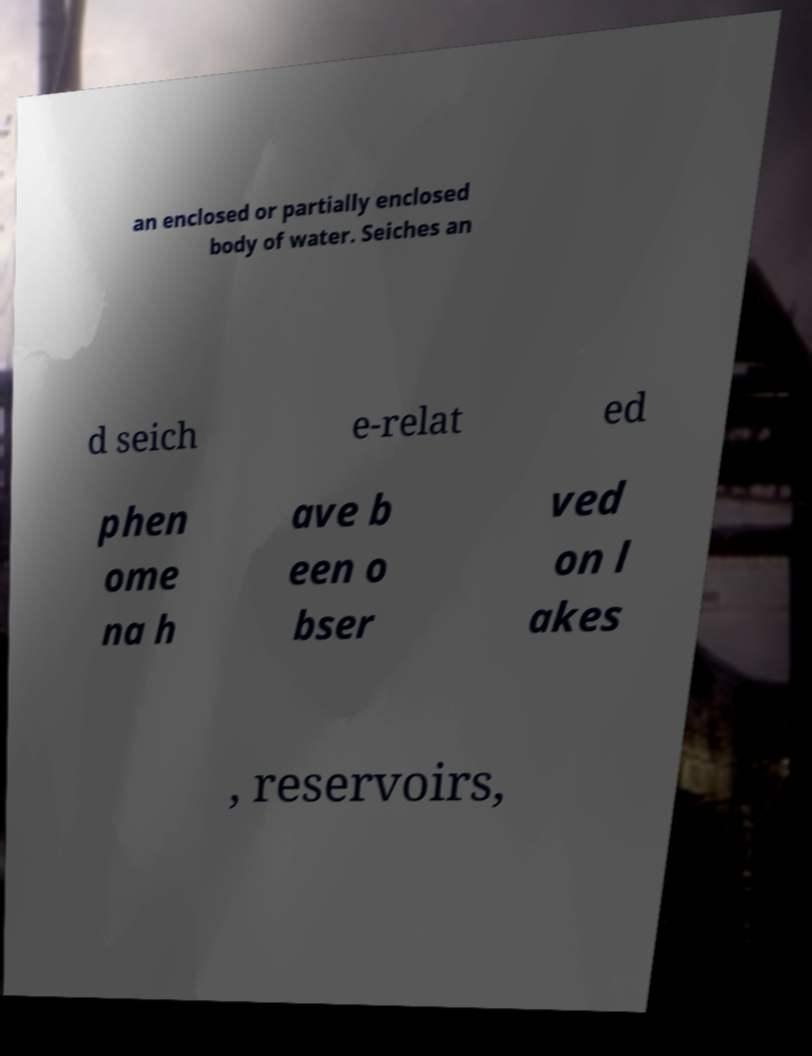Could you extract and type out the text from this image? an enclosed or partially enclosed body of water. Seiches an d seich e-relat ed phen ome na h ave b een o bser ved on l akes , reservoirs, 